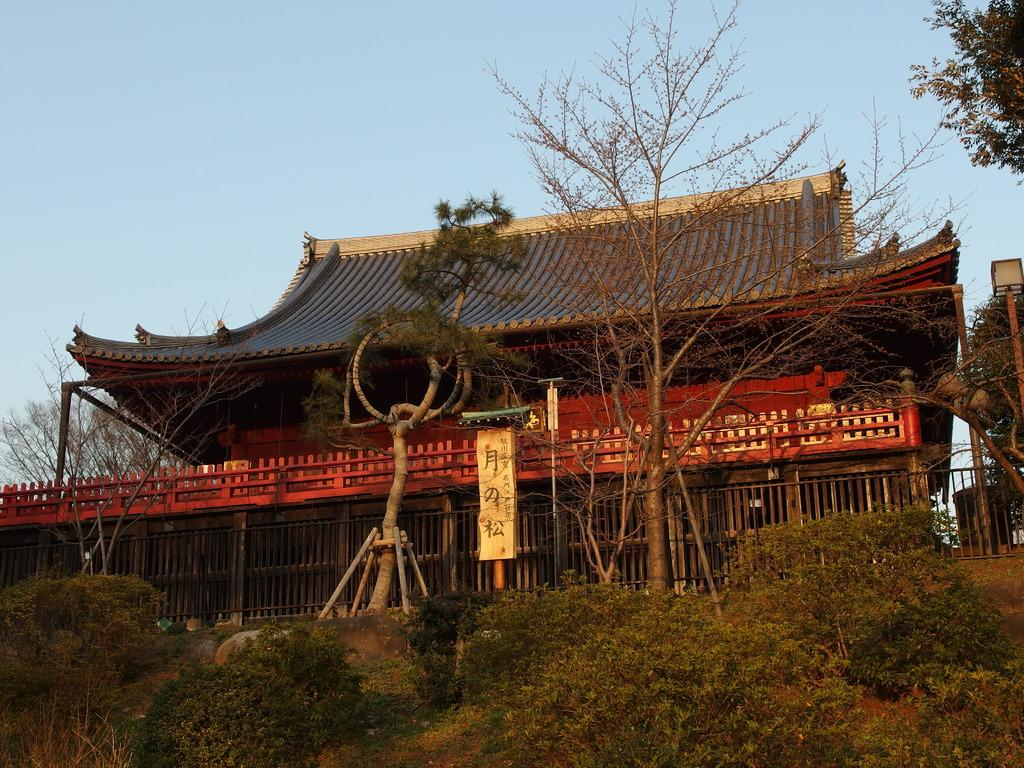What type of structure is present in the image? There is a building in the image. What can be seen on the building in the image? There is a poster with text on the building in the image. What type of vegetation is present in the image? There are trees and plants in the image. What architectural feature can be seen in the image? There is a pole in the image. What type of barrier is present in the image? There is fencing in the image. What part of the natural environment is visible in the image? The sky is visible in the image. How many pizzas are stacked on the floor in the image? There are no pizzas present in the image. What is the increase in temperature due to the presence of the poster in the image? The provided facts do not mention any temperature changes or the poster's effect on temperature. 